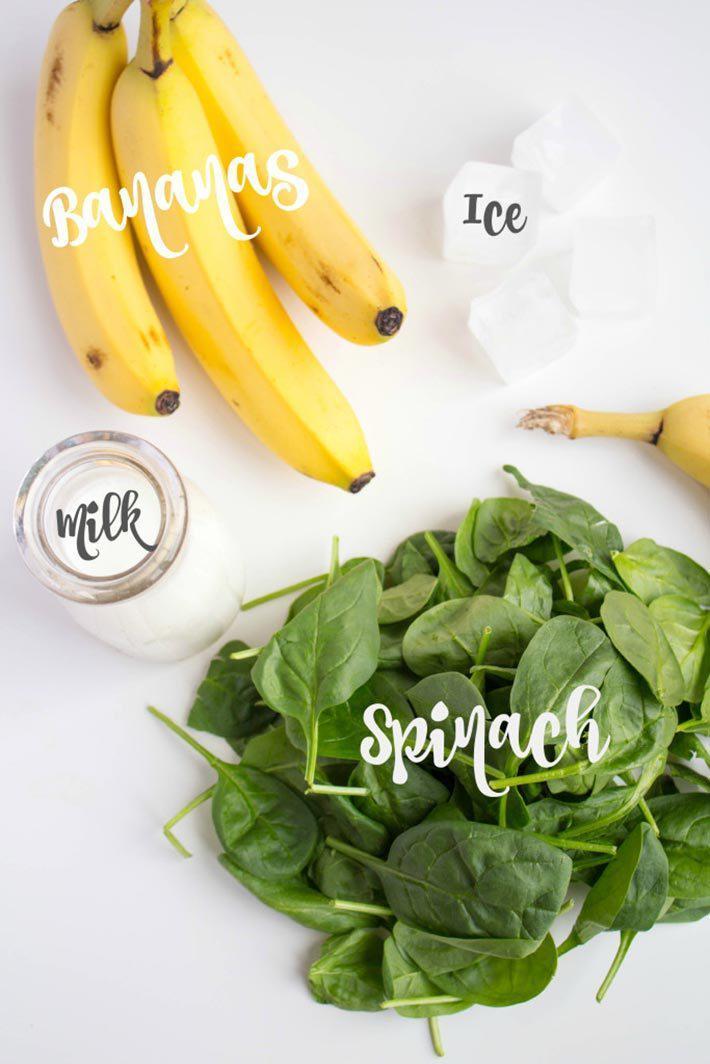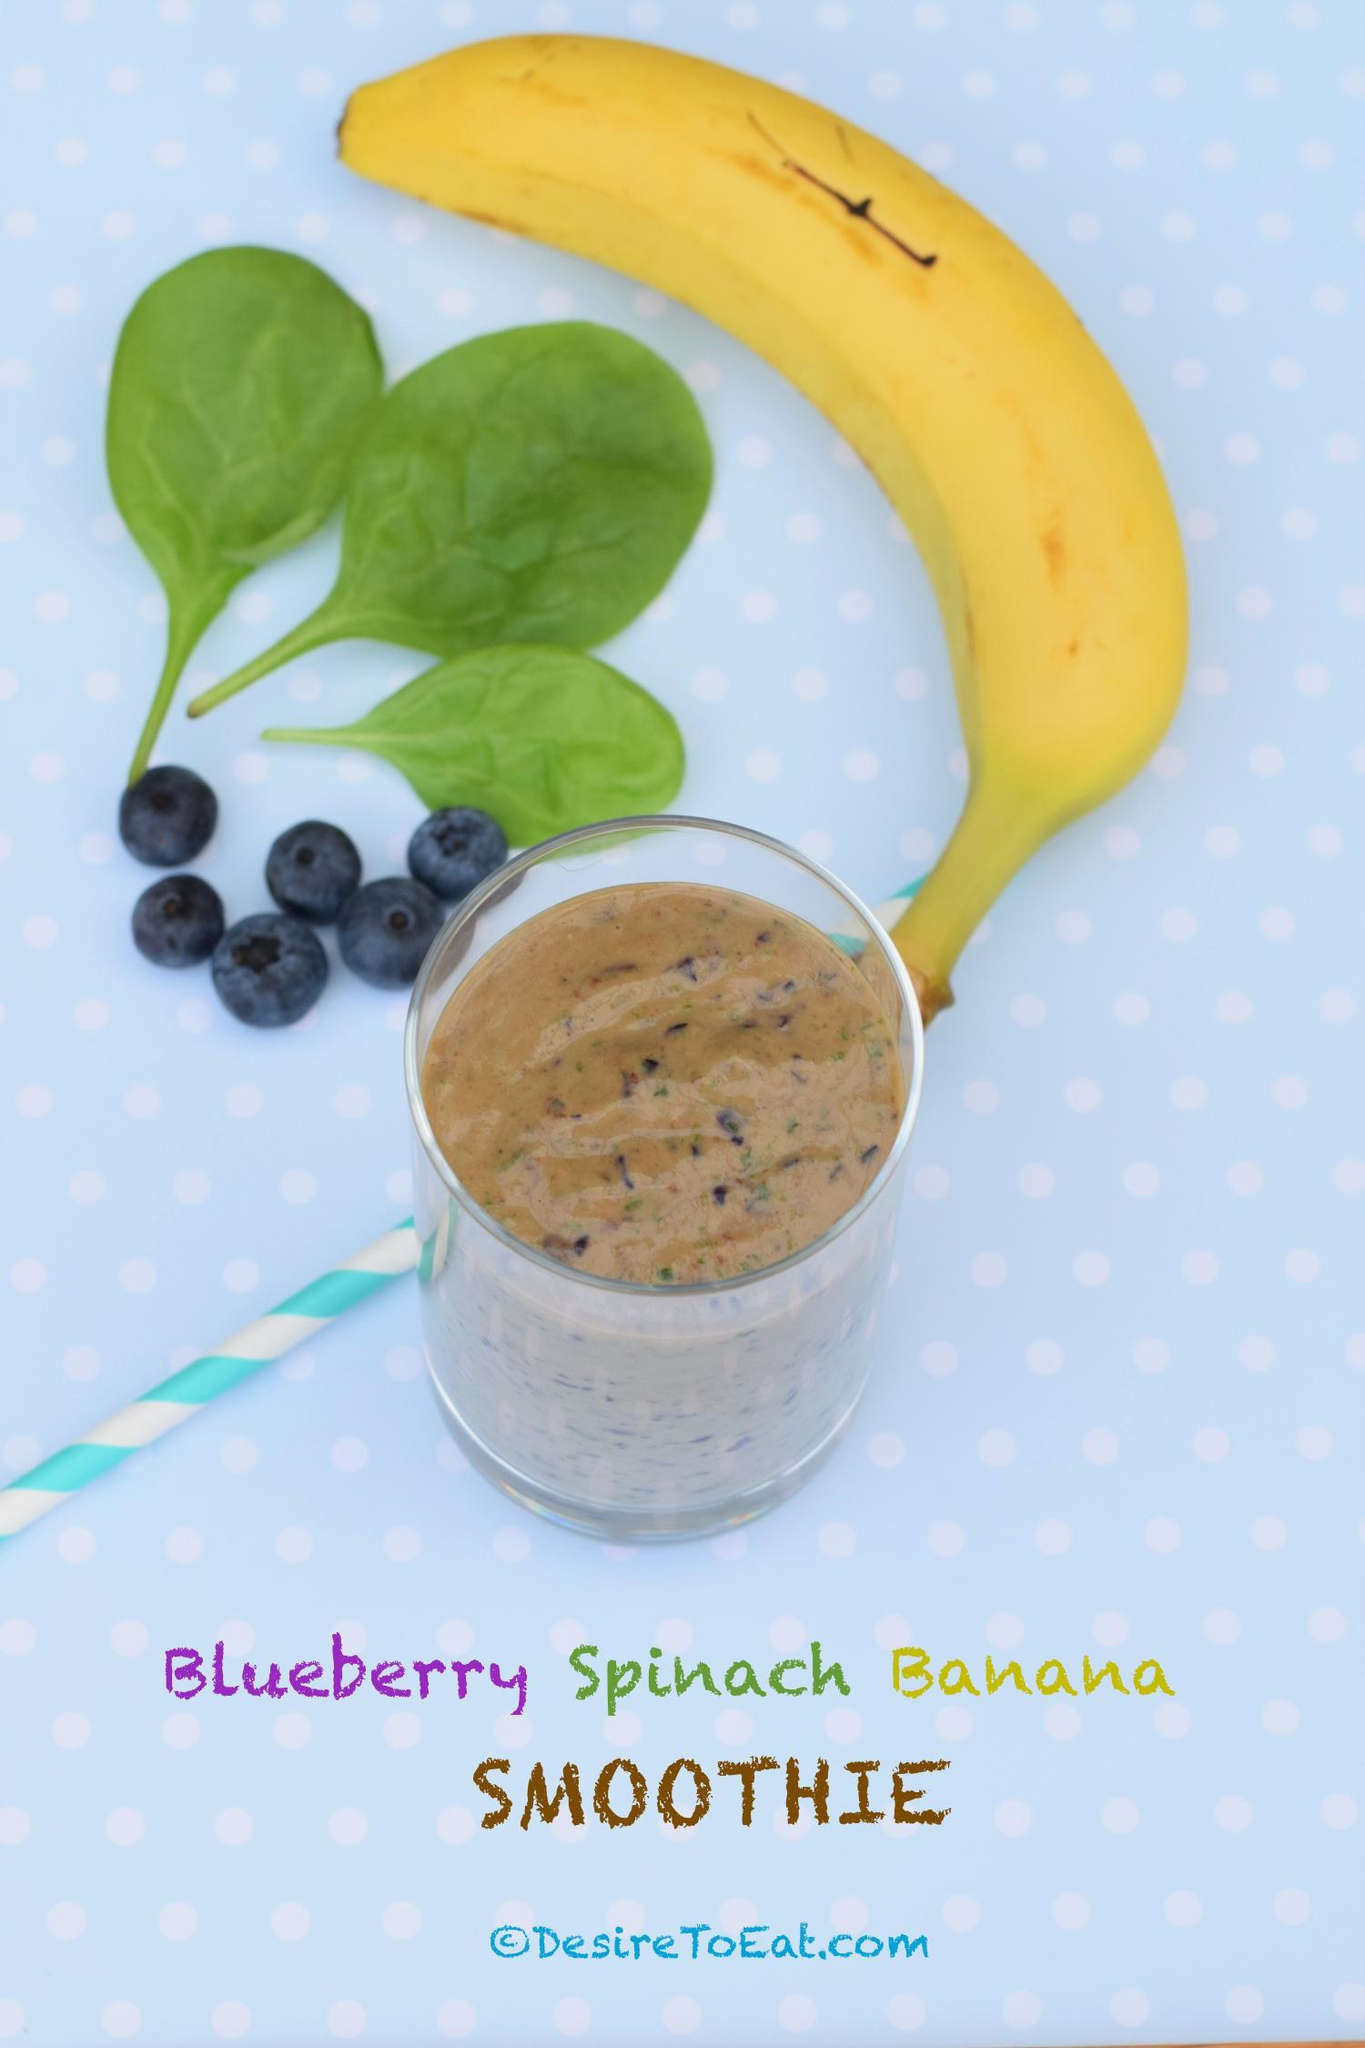The first image is the image on the left, the second image is the image on the right. Analyze the images presented: Is the assertion "The image on the left has at least one striped straw." valid? Answer yes or no. No. The first image is the image on the left, the second image is the image on the right. Analyze the images presented: Is the assertion "An image shows exactly one creamy green drink served in a footed glass." valid? Answer yes or no. No. 